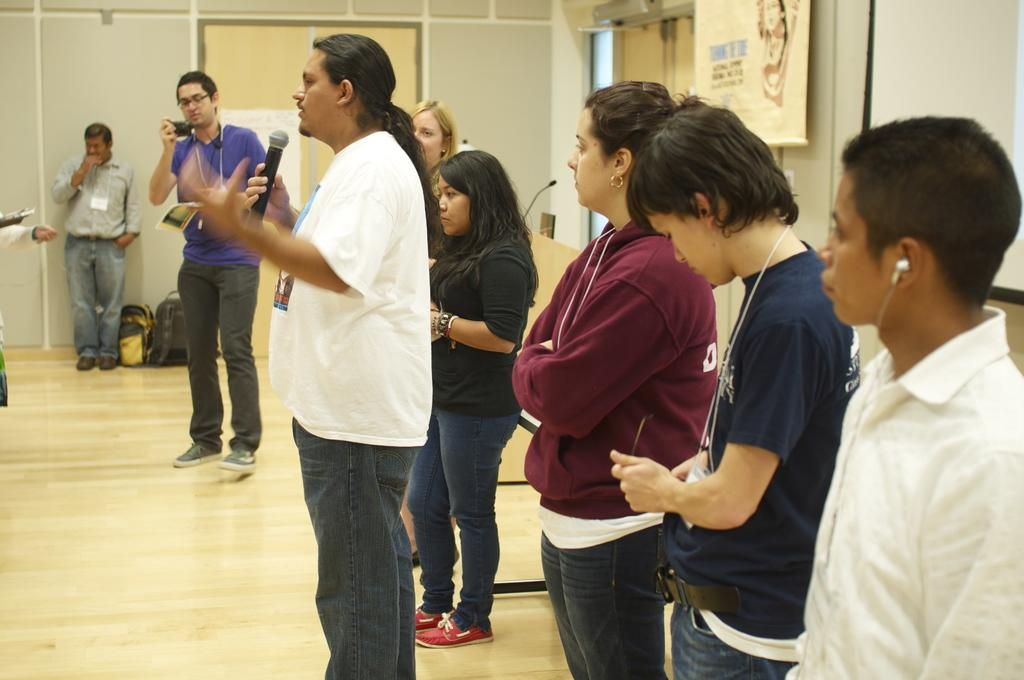What are the people in the image doing? There are persons standing on the floor, and one person is talking on a microphone. What objects can be seen in the image related to the person speaking? There is a microphone in the image that the person is using. What items are visible in the image that might belong to the people? There are bags in the image that might belong to the people. What is hanging on the wall in the background of the image? There is a poster in the image hanging on the wall. What type of watch is the person wearing in the image? There is no watch visible on any person in the image. How does the treatment for the person speaking on the microphone change throughout the image? There is no indication of any treatment or medical condition in the image, so this question cannot be answered. 